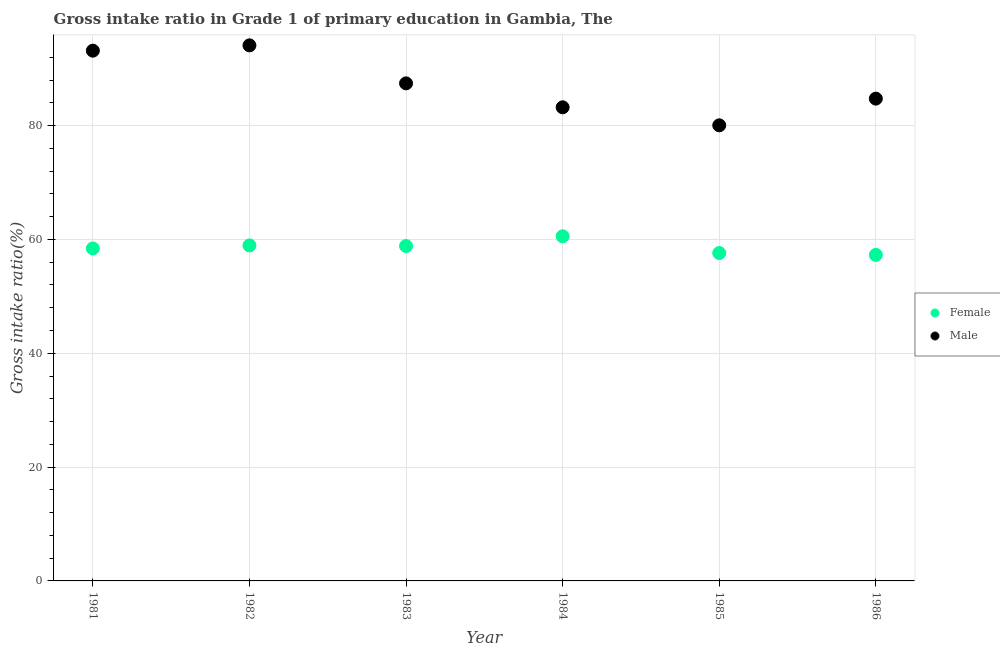What is the gross intake ratio(female) in 1984?
Your answer should be very brief. 60.55. Across all years, what is the maximum gross intake ratio(male)?
Ensure brevity in your answer.  94.1. Across all years, what is the minimum gross intake ratio(female)?
Make the answer very short. 57.28. In which year was the gross intake ratio(female) maximum?
Keep it short and to the point. 1984. What is the total gross intake ratio(female) in the graph?
Your response must be concise. 351.64. What is the difference between the gross intake ratio(female) in 1982 and that in 1984?
Your answer should be very brief. -1.6. What is the difference between the gross intake ratio(female) in 1982 and the gross intake ratio(male) in 1984?
Your answer should be very brief. -24.26. What is the average gross intake ratio(female) per year?
Keep it short and to the point. 58.61. In the year 1982, what is the difference between the gross intake ratio(female) and gross intake ratio(male)?
Your answer should be very brief. -35.15. In how many years, is the gross intake ratio(male) greater than 20 %?
Ensure brevity in your answer.  6. What is the ratio of the gross intake ratio(male) in 1982 to that in 1984?
Offer a very short reply. 1.13. Is the difference between the gross intake ratio(female) in 1983 and 1985 greater than the difference between the gross intake ratio(male) in 1983 and 1985?
Your response must be concise. No. What is the difference between the highest and the second highest gross intake ratio(male)?
Your answer should be compact. 0.93. What is the difference between the highest and the lowest gross intake ratio(male)?
Keep it short and to the point. 14.05. Is the sum of the gross intake ratio(female) in 1984 and 1985 greater than the maximum gross intake ratio(male) across all years?
Keep it short and to the point. Yes. Does the gross intake ratio(male) monotonically increase over the years?
Provide a succinct answer. No. Is the gross intake ratio(female) strictly greater than the gross intake ratio(male) over the years?
Give a very brief answer. No. Is the gross intake ratio(male) strictly less than the gross intake ratio(female) over the years?
Your response must be concise. No. How many years are there in the graph?
Ensure brevity in your answer.  6. Are the values on the major ticks of Y-axis written in scientific E-notation?
Your response must be concise. No. Does the graph contain grids?
Ensure brevity in your answer.  Yes. Where does the legend appear in the graph?
Offer a terse response. Center right. What is the title of the graph?
Offer a very short reply. Gross intake ratio in Grade 1 of primary education in Gambia, The. What is the label or title of the X-axis?
Keep it short and to the point. Year. What is the label or title of the Y-axis?
Your response must be concise. Gross intake ratio(%). What is the Gross intake ratio(%) in Female in 1981?
Your answer should be compact. 58.41. What is the Gross intake ratio(%) of Male in 1981?
Keep it short and to the point. 93.16. What is the Gross intake ratio(%) in Female in 1982?
Make the answer very short. 58.95. What is the Gross intake ratio(%) in Male in 1982?
Your answer should be very brief. 94.1. What is the Gross intake ratio(%) of Female in 1983?
Provide a succinct answer. 58.84. What is the Gross intake ratio(%) in Male in 1983?
Your answer should be compact. 87.42. What is the Gross intake ratio(%) of Female in 1984?
Provide a short and direct response. 60.55. What is the Gross intake ratio(%) in Male in 1984?
Offer a terse response. 83.21. What is the Gross intake ratio(%) of Female in 1985?
Provide a short and direct response. 57.6. What is the Gross intake ratio(%) in Male in 1985?
Your answer should be compact. 80.04. What is the Gross intake ratio(%) in Female in 1986?
Your response must be concise. 57.28. What is the Gross intake ratio(%) of Male in 1986?
Make the answer very short. 84.73. Across all years, what is the maximum Gross intake ratio(%) in Female?
Ensure brevity in your answer.  60.55. Across all years, what is the maximum Gross intake ratio(%) of Male?
Provide a short and direct response. 94.1. Across all years, what is the minimum Gross intake ratio(%) in Female?
Provide a short and direct response. 57.28. Across all years, what is the minimum Gross intake ratio(%) of Male?
Your answer should be very brief. 80.04. What is the total Gross intake ratio(%) in Female in the graph?
Provide a short and direct response. 351.64. What is the total Gross intake ratio(%) in Male in the graph?
Offer a very short reply. 522.66. What is the difference between the Gross intake ratio(%) of Female in 1981 and that in 1982?
Your response must be concise. -0.54. What is the difference between the Gross intake ratio(%) of Male in 1981 and that in 1982?
Ensure brevity in your answer.  -0.93. What is the difference between the Gross intake ratio(%) in Female in 1981 and that in 1983?
Your answer should be compact. -0.42. What is the difference between the Gross intake ratio(%) in Male in 1981 and that in 1983?
Offer a terse response. 5.74. What is the difference between the Gross intake ratio(%) in Female in 1981 and that in 1984?
Your answer should be compact. -2.14. What is the difference between the Gross intake ratio(%) in Male in 1981 and that in 1984?
Provide a short and direct response. 9.95. What is the difference between the Gross intake ratio(%) of Female in 1981 and that in 1985?
Your response must be concise. 0.81. What is the difference between the Gross intake ratio(%) of Male in 1981 and that in 1985?
Offer a very short reply. 13.12. What is the difference between the Gross intake ratio(%) in Female in 1981 and that in 1986?
Offer a very short reply. 1.13. What is the difference between the Gross intake ratio(%) in Male in 1981 and that in 1986?
Keep it short and to the point. 8.43. What is the difference between the Gross intake ratio(%) of Female in 1982 and that in 1983?
Ensure brevity in your answer.  0.11. What is the difference between the Gross intake ratio(%) of Male in 1982 and that in 1983?
Keep it short and to the point. 6.68. What is the difference between the Gross intake ratio(%) of Female in 1982 and that in 1984?
Your answer should be very brief. -1.6. What is the difference between the Gross intake ratio(%) in Male in 1982 and that in 1984?
Your response must be concise. 10.88. What is the difference between the Gross intake ratio(%) of Female in 1982 and that in 1985?
Offer a very short reply. 1.35. What is the difference between the Gross intake ratio(%) in Male in 1982 and that in 1985?
Give a very brief answer. 14.05. What is the difference between the Gross intake ratio(%) of Female in 1982 and that in 1986?
Your response must be concise. 1.67. What is the difference between the Gross intake ratio(%) in Male in 1982 and that in 1986?
Provide a short and direct response. 9.36. What is the difference between the Gross intake ratio(%) of Female in 1983 and that in 1984?
Keep it short and to the point. -1.71. What is the difference between the Gross intake ratio(%) of Male in 1983 and that in 1984?
Make the answer very short. 4.21. What is the difference between the Gross intake ratio(%) in Female in 1983 and that in 1985?
Your answer should be very brief. 1.24. What is the difference between the Gross intake ratio(%) in Male in 1983 and that in 1985?
Keep it short and to the point. 7.37. What is the difference between the Gross intake ratio(%) in Female in 1983 and that in 1986?
Your answer should be very brief. 1.56. What is the difference between the Gross intake ratio(%) of Male in 1983 and that in 1986?
Keep it short and to the point. 2.68. What is the difference between the Gross intake ratio(%) of Female in 1984 and that in 1985?
Give a very brief answer. 2.95. What is the difference between the Gross intake ratio(%) in Male in 1984 and that in 1985?
Give a very brief answer. 3.17. What is the difference between the Gross intake ratio(%) of Female in 1984 and that in 1986?
Your answer should be very brief. 3.27. What is the difference between the Gross intake ratio(%) in Male in 1984 and that in 1986?
Provide a succinct answer. -1.52. What is the difference between the Gross intake ratio(%) in Female in 1985 and that in 1986?
Provide a succinct answer. 0.32. What is the difference between the Gross intake ratio(%) of Male in 1985 and that in 1986?
Your answer should be very brief. -4.69. What is the difference between the Gross intake ratio(%) in Female in 1981 and the Gross intake ratio(%) in Male in 1982?
Provide a succinct answer. -35.68. What is the difference between the Gross intake ratio(%) in Female in 1981 and the Gross intake ratio(%) in Male in 1983?
Offer a very short reply. -29. What is the difference between the Gross intake ratio(%) of Female in 1981 and the Gross intake ratio(%) of Male in 1984?
Ensure brevity in your answer.  -24.8. What is the difference between the Gross intake ratio(%) of Female in 1981 and the Gross intake ratio(%) of Male in 1985?
Offer a very short reply. -21.63. What is the difference between the Gross intake ratio(%) in Female in 1981 and the Gross intake ratio(%) in Male in 1986?
Provide a succinct answer. -26.32. What is the difference between the Gross intake ratio(%) of Female in 1982 and the Gross intake ratio(%) of Male in 1983?
Offer a very short reply. -28.47. What is the difference between the Gross intake ratio(%) of Female in 1982 and the Gross intake ratio(%) of Male in 1984?
Make the answer very short. -24.26. What is the difference between the Gross intake ratio(%) of Female in 1982 and the Gross intake ratio(%) of Male in 1985?
Ensure brevity in your answer.  -21.09. What is the difference between the Gross intake ratio(%) in Female in 1982 and the Gross intake ratio(%) in Male in 1986?
Your response must be concise. -25.79. What is the difference between the Gross intake ratio(%) of Female in 1983 and the Gross intake ratio(%) of Male in 1984?
Offer a very short reply. -24.37. What is the difference between the Gross intake ratio(%) of Female in 1983 and the Gross intake ratio(%) of Male in 1985?
Your response must be concise. -21.2. What is the difference between the Gross intake ratio(%) of Female in 1983 and the Gross intake ratio(%) of Male in 1986?
Your answer should be compact. -25.9. What is the difference between the Gross intake ratio(%) of Female in 1984 and the Gross intake ratio(%) of Male in 1985?
Keep it short and to the point. -19.49. What is the difference between the Gross intake ratio(%) of Female in 1984 and the Gross intake ratio(%) of Male in 1986?
Make the answer very short. -24.18. What is the difference between the Gross intake ratio(%) in Female in 1985 and the Gross intake ratio(%) in Male in 1986?
Ensure brevity in your answer.  -27.13. What is the average Gross intake ratio(%) in Female per year?
Provide a succinct answer. 58.61. What is the average Gross intake ratio(%) of Male per year?
Offer a very short reply. 87.11. In the year 1981, what is the difference between the Gross intake ratio(%) of Female and Gross intake ratio(%) of Male?
Give a very brief answer. -34.75. In the year 1982, what is the difference between the Gross intake ratio(%) of Female and Gross intake ratio(%) of Male?
Your answer should be compact. -35.15. In the year 1983, what is the difference between the Gross intake ratio(%) in Female and Gross intake ratio(%) in Male?
Offer a terse response. -28.58. In the year 1984, what is the difference between the Gross intake ratio(%) of Female and Gross intake ratio(%) of Male?
Provide a succinct answer. -22.66. In the year 1985, what is the difference between the Gross intake ratio(%) in Female and Gross intake ratio(%) in Male?
Offer a very short reply. -22.44. In the year 1986, what is the difference between the Gross intake ratio(%) of Female and Gross intake ratio(%) of Male?
Provide a succinct answer. -27.45. What is the ratio of the Gross intake ratio(%) of Female in 1981 to that in 1982?
Keep it short and to the point. 0.99. What is the ratio of the Gross intake ratio(%) in Male in 1981 to that in 1982?
Make the answer very short. 0.99. What is the ratio of the Gross intake ratio(%) in Female in 1981 to that in 1983?
Your response must be concise. 0.99. What is the ratio of the Gross intake ratio(%) of Male in 1981 to that in 1983?
Give a very brief answer. 1.07. What is the ratio of the Gross intake ratio(%) in Female in 1981 to that in 1984?
Keep it short and to the point. 0.96. What is the ratio of the Gross intake ratio(%) of Male in 1981 to that in 1984?
Make the answer very short. 1.12. What is the ratio of the Gross intake ratio(%) of Female in 1981 to that in 1985?
Give a very brief answer. 1.01. What is the ratio of the Gross intake ratio(%) of Male in 1981 to that in 1985?
Offer a terse response. 1.16. What is the ratio of the Gross intake ratio(%) of Female in 1981 to that in 1986?
Make the answer very short. 1.02. What is the ratio of the Gross intake ratio(%) of Male in 1981 to that in 1986?
Provide a short and direct response. 1.1. What is the ratio of the Gross intake ratio(%) in Female in 1982 to that in 1983?
Provide a short and direct response. 1. What is the ratio of the Gross intake ratio(%) in Male in 1982 to that in 1983?
Ensure brevity in your answer.  1.08. What is the ratio of the Gross intake ratio(%) of Female in 1982 to that in 1984?
Offer a terse response. 0.97. What is the ratio of the Gross intake ratio(%) in Male in 1982 to that in 1984?
Ensure brevity in your answer.  1.13. What is the ratio of the Gross intake ratio(%) in Female in 1982 to that in 1985?
Provide a succinct answer. 1.02. What is the ratio of the Gross intake ratio(%) of Male in 1982 to that in 1985?
Offer a very short reply. 1.18. What is the ratio of the Gross intake ratio(%) of Female in 1982 to that in 1986?
Ensure brevity in your answer.  1.03. What is the ratio of the Gross intake ratio(%) in Male in 1982 to that in 1986?
Offer a very short reply. 1.11. What is the ratio of the Gross intake ratio(%) in Female in 1983 to that in 1984?
Keep it short and to the point. 0.97. What is the ratio of the Gross intake ratio(%) of Male in 1983 to that in 1984?
Keep it short and to the point. 1.05. What is the ratio of the Gross intake ratio(%) of Female in 1983 to that in 1985?
Offer a very short reply. 1.02. What is the ratio of the Gross intake ratio(%) in Male in 1983 to that in 1985?
Offer a terse response. 1.09. What is the ratio of the Gross intake ratio(%) of Female in 1983 to that in 1986?
Offer a very short reply. 1.03. What is the ratio of the Gross intake ratio(%) of Male in 1983 to that in 1986?
Make the answer very short. 1.03. What is the ratio of the Gross intake ratio(%) of Female in 1984 to that in 1985?
Keep it short and to the point. 1.05. What is the ratio of the Gross intake ratio(%) in Male in 1984 to that in 1985?
Ensure brevity in your answer.  1.04. What is the ratio of the Gross intake ratio(%) of Female in 1984 to that in 1986?
Your answer should be very brief. 1.06. What is the ratio of the Gross intake ratio(%) of Female in 1985 to that in 1986?
Your response must be concise. 1.01. What is the ratio of the Gross intake ratio(%) in Male in 1985 to that in 1986?
Keep it short and to the point. 0.94. What is the difference between the highest and the second highest Gross intake ratio(%) of Female?
Offer a very short reply. 1.6. What is the difference between the highest and the second highest Gross intake ratio(%) of Male?
Provide a short and direct response. 0.93. What is the difference between the highest and the lowest Gross intake ratio(%) in Female?
Make the answer very short. 3.27. What is the difference between the highest and the lowest Gross intake ratio(%) in Male?
Provide a short and direct response. 14.05. 